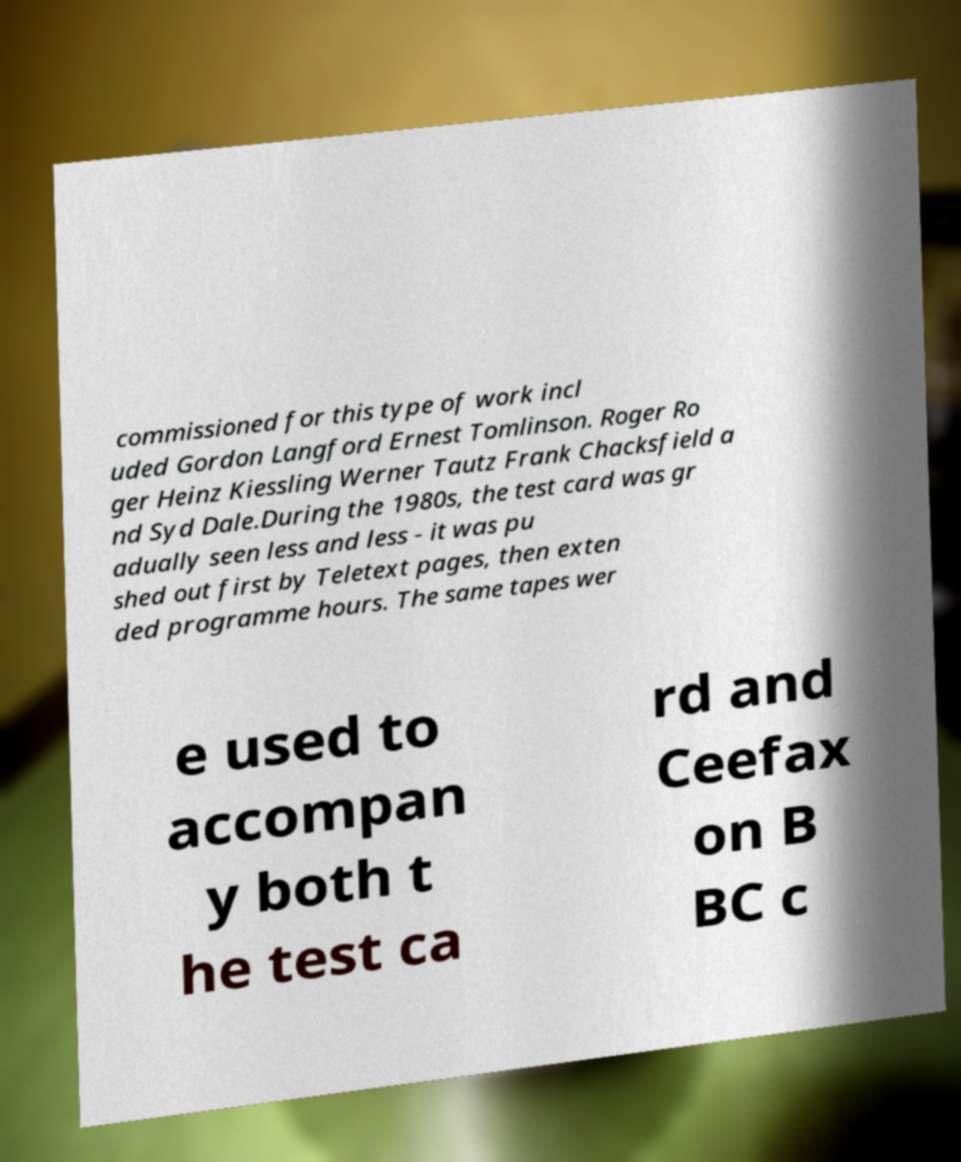Could you extract and type out the text from this image? commissioned for this type of work incl uded Gordon Langford Ernest Tomlinson. Roger Ro ger Heinz Kiessling Werner Tautz Frank Chacksfield a nd Syd Dale.During the 1980s, the test card was gr adually seen less and less - it was pu shed out first by Teletext pages, then exten ded programme hours. The same tapes wer e used to accompan y both t he test ca rd and Ceefax on B BC c 